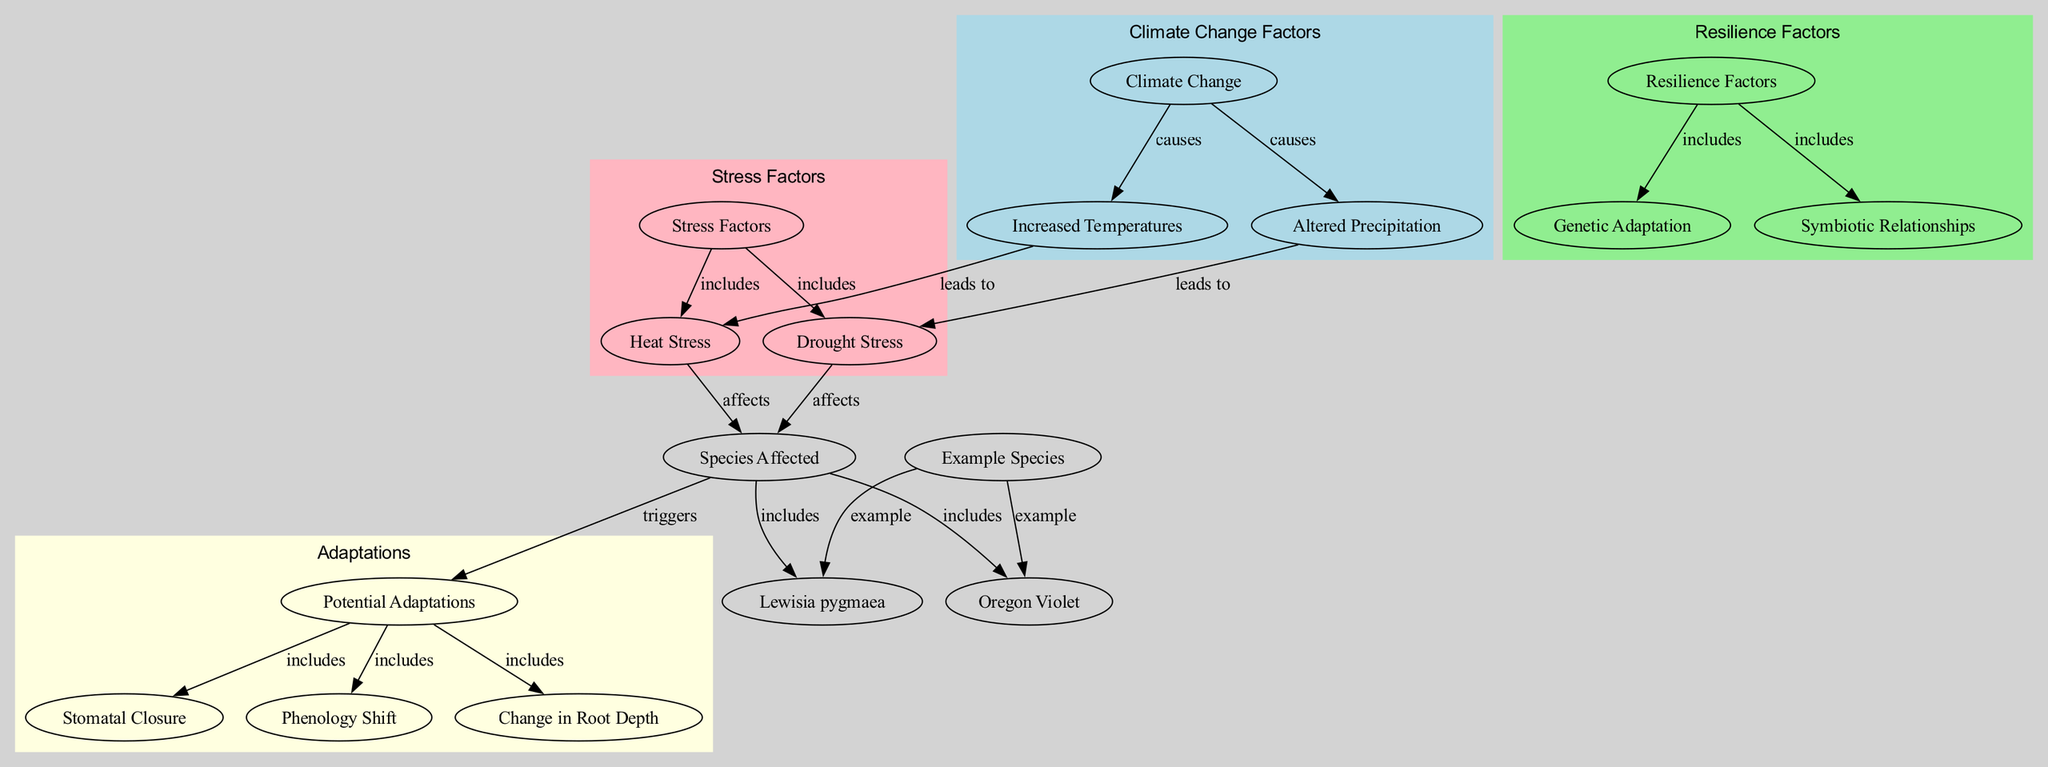What major factors contribute to climate change according to the diagram? The diagram shows that the major factors contributing to climate change are increased temperatures and altered precipitation, which are directly connected to the node labeled "Climate Change."
Answer: Increased temperatures, altered precipitation Which stress factor is directly linked to increased temperatures? The diagram has an edge labeled "leads to" from the "increased temperatures" node to the "heat stress" node, indicating that increased temperatures result in heat stress.
Answer: Heat stress How many species are affected by the stress factors illustrated in the diagram? The connection from "species affected" includes nodes for "lewisia pygmaea" and "oregon violet," making a total of two species specifically indicated as affected by the stress factors.
Answer: 2 What adaptations are triggered by the species affected by stress factors? According to the diagram, the "species affected" node has a direct edge labeled "triggers" leading to the "adaptations" node, indicating that the stress factors cause various adaptations, which include stomatal closure, phenology shift, and change in root depth.
Answer: Stomatal closure, phenology shift, change in root depth Which resilience factor is associated with genetic adaptation? The diagram shows an edge labeled "includes" from the "resilience factors" node to the "genetic adaptation" node, highlighting that genetic adaptation is one of the components of resilience factors.
Answer: Genetic adaptation How does altered precipitation affect alpine flora? The diagram displays an edge labeled "leads to" from "altered precipitation" to "drought stress," which indicates that changes in precipitation patterns directly contribute to drought stress in alpine flora.
Answer: Drought stress What are the two types of stress factors represented in the diagram? The diagram contains the stress factors node, which has edges leading to "heat stress" and "drought stress," indicating these are the two types of stress factors represented.
Answer: Heat stress, drought stress Which node represents example species that are affected by climate change? The "species" node in the diagram illustrates the specific example species affected, which are "lewisia pygmaea" and "oregon violet," both connected to the species affected node.
Answer: Lewisia pygmaea, Oregon violet 